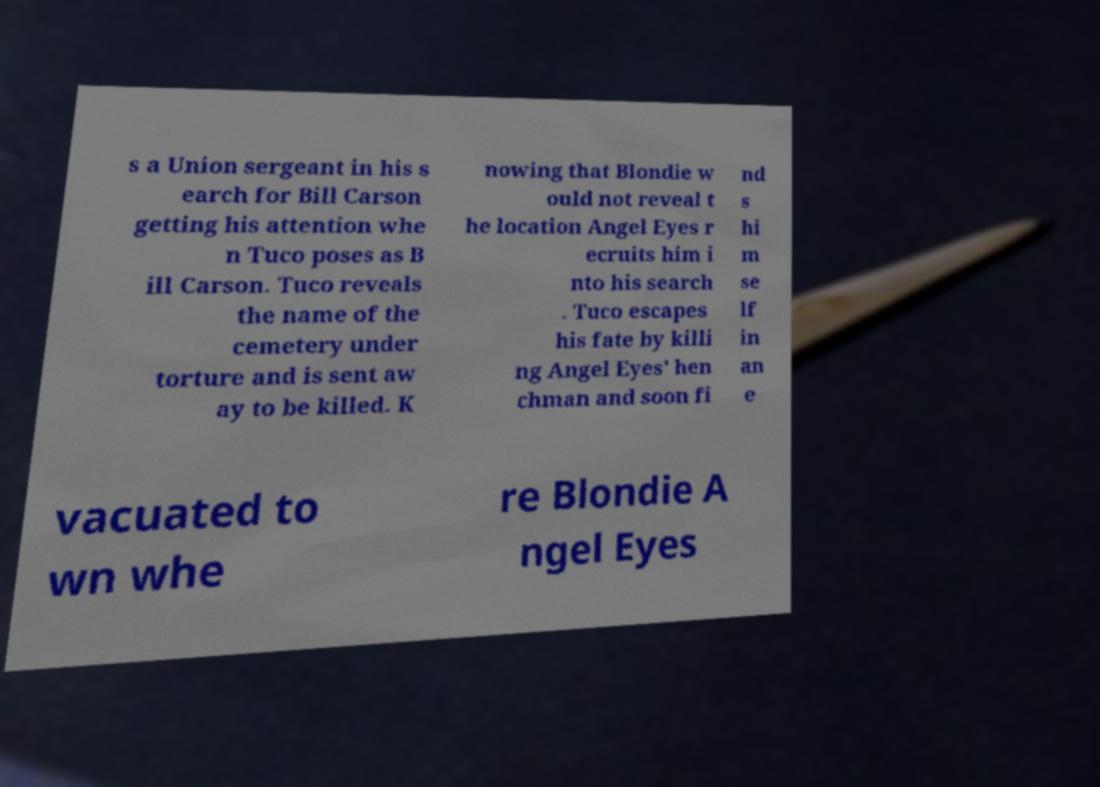Can you read and provide the text displayed in the image?This photo seems to have some interesting text. Can you extract and type it out for me? s a Union sergeant in his s earch for Bill Carson getting his attention whe n Tuco poses as B ill Carson. Tuco reveals the name of the cemetery under torture and is sent aw ay to be killed. K nowing that Blondie w ould not reveal t he location Angel Eyes r ecruits him i nto his search . Tuco escapes his fate by killi ng Angel Eyes' hen chman and soon fi nd s hi m se lf in an e vacuated to wn whe re Blondie A ngel Eyes 